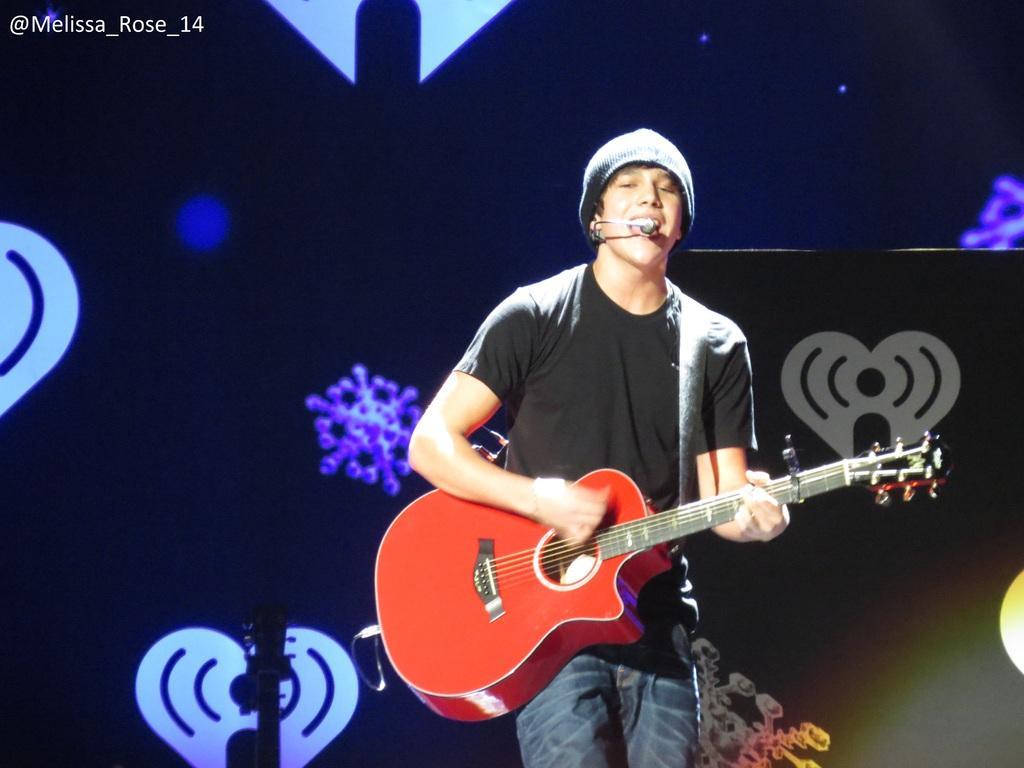Could you give a brief overview of what you see in this image? A boy with black t-shirt is singing and playing guitar. He is standing. He is wearing a cap on his head. In the background there is black color light and some designs over it. 